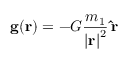Convert formula to latex. <formula><loc_0><loc_0><loc_500><loc_500>g ( r ) = - G { \frac { m _ { 1 } } { { | r | } ^ { 2 } } } \, \hat { r }</formula> 